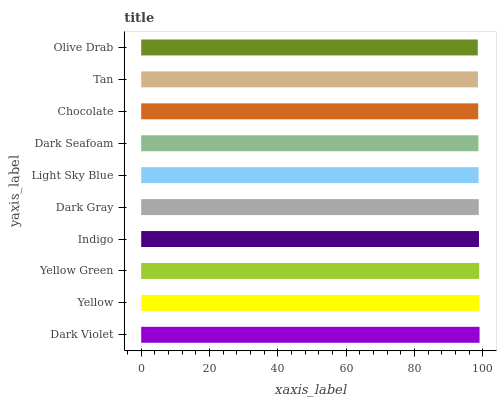Is Olive Drab the minimum?
Answer yes or no. Yes. Is Dark Violet the maximum?
Answer yes or no. Yes. Is Yellow the minimum?
Answer yes or no. No. Is Yellow the maximum?
Answer yes or no. No. Is Dark Violet greater than Yellow?
Answer yes or no. Yes. Is Yellow less than Dark Violet?
Answer yes or no. Yes. Is Yellow greater than Dark Violet?
Answer yes or no. No. Is Dark Violet less than Yellow?
Answer yes or no. No. Is Dark Gray the high median?
Answer yes or no. Yes. Is Light Sky Blue the low median?
Answer yes or no. Yes. Is Dark Violet the high median?
Answer yes or no. No. Is Tan the low median?
Answer yes or no. No. 